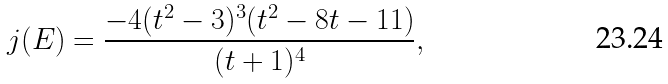<formula> <loc_0><loc_0><loc_500><loc_500>j ( E ) = \frac { - 4 ( t ^ { 2 } - 3 ) ^ { 3 } ( t ^ { 2 } - 8 t - 1 1 ) } { ( t + 1 ) ^ { 4 } } ,</formula> 